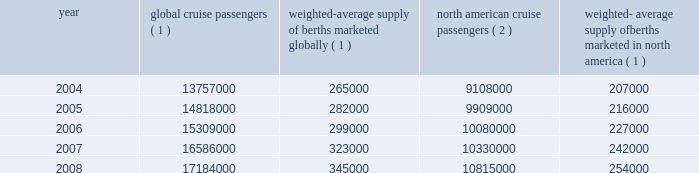Royal caribbean cruises ltd .
3 part i the table details the growth in the global and north american cruise markets in terms of cruise passengers and estimated weighted- average berths over the past five years : weighted-average weighted-average north american supply of berths global cruise supply of berths cruise marketed in year passengers ( 1 ) marketed globally ( 1 ) passengers ( 2 ) north america ( 1 ) .
( 1 ) source : our estimates .
( 2 ) source : cruise line international association based on cruise passengers carried for at least two consecutive nights .
In an effort to penetrate untapped markets and diversify our customer base , we have redeployed some of the ships in our royal caribbean international and celebrity cruises brands from the north american market to europe , latin america and asia .
This redeployment has contributed to an increase in the growth of our global cruise brands outside of the north american market .
Although the global and north american cruise markets have grown steadily over the past several years , the recent weakening of the united states and other economies has significantly deteriorated consumer confidence and discretionary spending .
This has caused a global drop in demand for cruises and a resulting drop in cruise prices .
The long-term impact of these conditions on the continued growth of the cruise mar- ket will depend on the depth and duration of this worldwide economic downturn .
In addition , the projected increase in capacity within the cruise industry from new cruise ships currently on order could produce addi- tional pricing pressures within the industry .
See item 1a .
Risk factors .
We compete with a number of cruise lines ; however , our principal competitors are carnival corporation & plc , which owns , among others , aida cruises , carnival cruise lines , costa cruises , cunard line , holland america line , p&o cruises and princess cruises and has a joint venture with orizonia corporation under which they operate iberocruceros ; disney cruise line ; msc cruises ; norwegian cruise line and oceania cruises .
Cruise lines compete with other vacation alter- natives such as land-based resort hotels and sightseeing destinations for consumers 2019 leisure time .
Demand for such activities is influenced by political and general economic conditions .
Companies within the vacation market are dependent on consumer discretionary spending .
Although vacation spending is likely to be curtailed significantly in the midst of the current worldwide economic downturn , we believe that cruising is perceived by consumers as a good value when compared to other vacation alternatives .
Our ships operate worldwide and have itineraries that call on destina- tions in alaska , asia , australia , the bahamas , bermuda , california , canada , the caribbean , europe , the galapagos islands , hawaii , mexico , new england , new zealand , the panama canal and south america .
Operating strategies our principal operating strategies are to : manage the efficiency of our operating expenditures and preserve cash and liquidity during the current worldwide economic downturn , increase the awareness and market penetration of our brands , expand our fleet with the new state-of-the-art cruise ships currently on order , expand into new markets and itineraries , continue to expand and diversify our passenger mix through passen- ger sourcing outside north america , protect the health , safety and security of our passengers and employees and protect the environment in which our vessels and organization operate , utilize sophisticated revenue management capabilities to optimize revenue based on demand for our products , further improve our technological capabilities , and maintain strong relationships with travel agencies , the principal indus- try distribution channel , while offering direct access for consumers .
Manage operating expenditures and preserve cash and liquidity during the current worldwide economic downturn we are focused on maximizing the efficiency of our operating expenditures and preserving cash and liquidity .
During 2008 , we announced the reduction in our workforce of approximately 400 shoreside positions and implemented a number of cost-saving initiatives in an effort to reduce our operating costs .
To preserve liquidity , we have discontinued our quarterly dividend commencing in the fourth quarter of 2008 , curtailed our non-shipbuild capital expenditures , and currently do not have plans to place further newbuild orders .
We believe these strategies will enhance our ability to fund our capital spending obligations and improve our balance sheet. .
In 2005 what was the percent of the weighted-average supply of berths marketed globally in marketed in north america? 
Computations: (207000 / 265000)
Answer: 0.78113. 